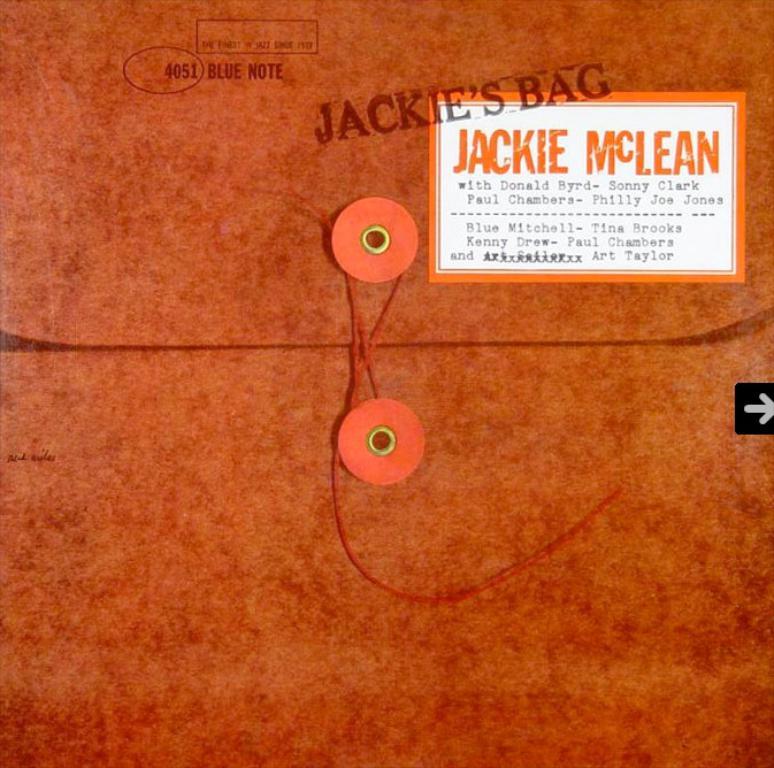Whose bag is this?
Offer a terse response. Jackie's. 